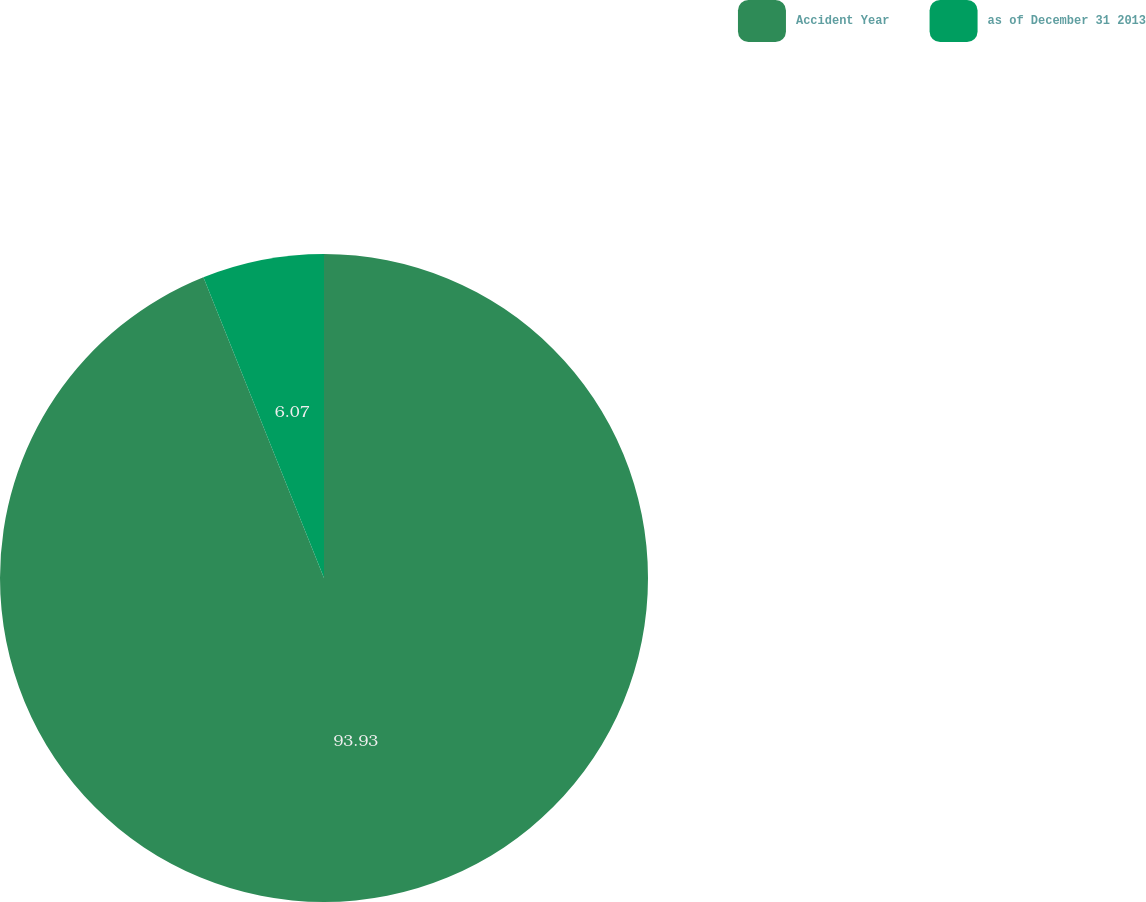<chart> <loc_0><loc_0><loc_500><loc_500><pie_chart><fcel>Accident Year<fcel>as of December 31 2013<nl><fcel>93.93%<fcel>6.07%<nl></chart> 